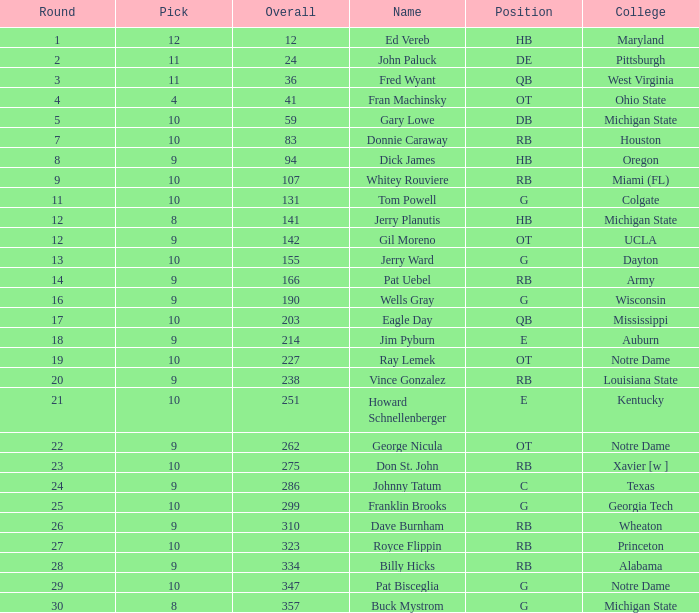What is the total number of overall picks that were after pick 9 and went to Auburn College? 0.0. 